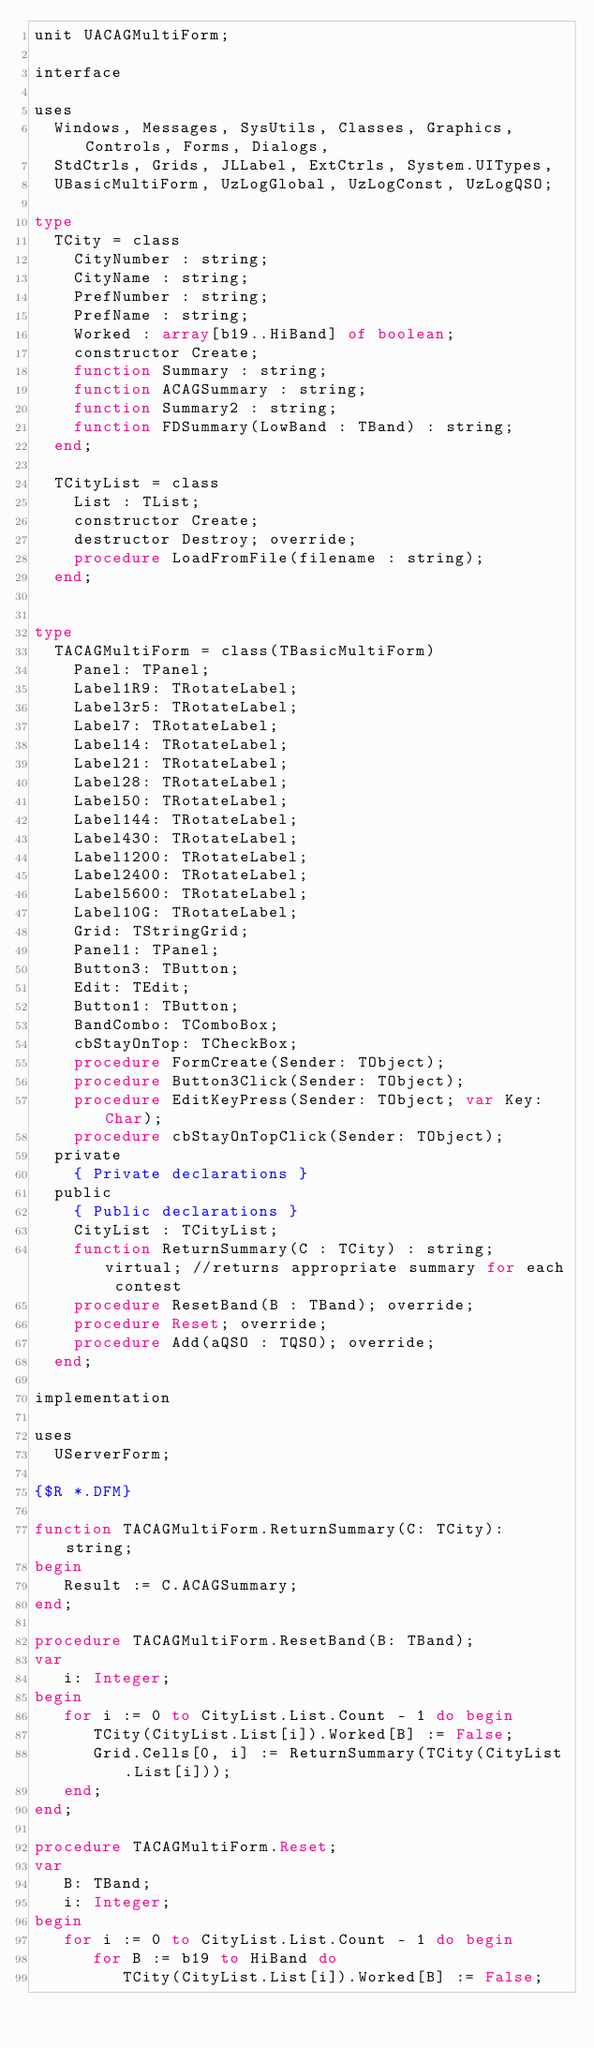<code> <loc_0><loc_0><loc_500><loc_500><_Pascal_>unit UACAGMultiForm;

interface

uses
  Windows, Messages, SysUtils, Classes, Graphics, Controls, Forms, Dialogs,
  StdCtrls, Grids, JLLabel, ExtCtrls, System.UITypes,
  UBasicMultiForm, UzLogGlobal, UzLogConst, UzLogQSO;

type
  TCity = class
    CityNumber : string;
    CityName : string;
    PrefNumber : string;
    PrefName : string;
    Worked : array[b19..HiBand] of boolean;
    constructor Create;
    function Summary : string;
    function ACAGSummary : string;
    function Summary2 : string;
    function FDSummary(LowBand : TBand) : string;
  end;

  TCityList = class
    List : TList;
    constructor Create;
    destructor Destroy; override;
    procedure LoadFromFile(filename : string);
  end;


type
  TACAGMultiForm = class(TBasicMultiForm)
    Panel: TPanel;
    Label1R9: TRotateLabel;
    Label3r5: TRotateLabel;
    Label7: TRotateLabel;
    Label14: TRotateLabel;
    Label21: TRotateLabel;
    Label28: TRotateLabel;
    Label50: TRotateLabel;
    Label144: TRotateLabel;
    Label430: TRotateLabel;
    Label1200: TRotateLabel;
    Label2400: TRotateLabel;
    Label5600: TRotateLabel;
    Label10G: TRotateLabel;
    Grid: TStringGrid;
    Panel1: TPanel;
    Button3: TButton;
    Edit: TEdit;
    Button1: TButton;
    BandCombo: TComboBox;
    cbStayOnTop: TCheckBox;
    procedure FormCreate(Sender: TObject);
    procedure Button3Click(Sender: TObject);
    procedure EditKeyPress(Sender: TObject; var Key: Char);
    procedure cbStayOnTopClick(Sender: TObject);
  private
    { Private declarations }
  public
    { Public declarations }
    CityList : TCityList;
    function ReturnSummary(C : TCity) : string; virtual; //returns appropriate summary for each contest
    procedure ResetBand(B : TBand); override;
    procedure Reset; override;
    procedure Add(aQSO : TQSO); override;
  end;

implementation

uses
  UServerForm;

{$R *.DFM}

function TACAGMultiForm.ReturnSummary(C: TCity): string;
begin
   Result := C.ACAGSummary;
end;

procedure TACAGMultiForm.ResetBand(B: TBand);
var
   i: Integer;
begin
   for i := 0 to CityList.List.Count - 1 do begin
      TCity(CityList.List[i]).Worked[B] := False;
      Grid.Cells[0, i] := ReturnSummary(TCity(CityList.List[i]));
   end;
end;

procedure TACAGMultiForm.Reset;
var
   B: TBand;
   i: Integer;
begin
   for i := 0 to CityList.List.Count - 1 do begin
      for B := b19 to HiBand do
         TCity(CityList.List[i]).Worked[B] := False;</code> 